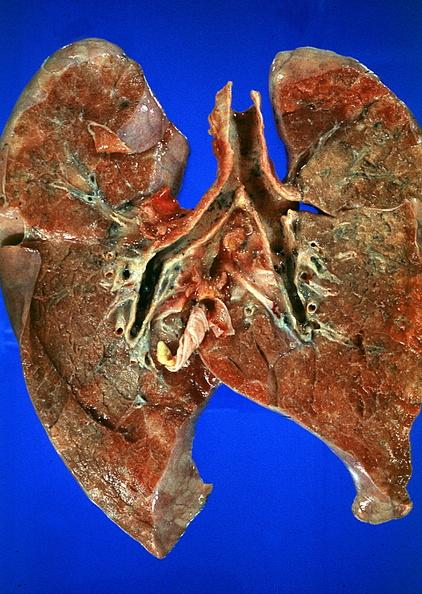do thermal burn smoke inhalation?
Answer the question using a single word or phrase. Yes 